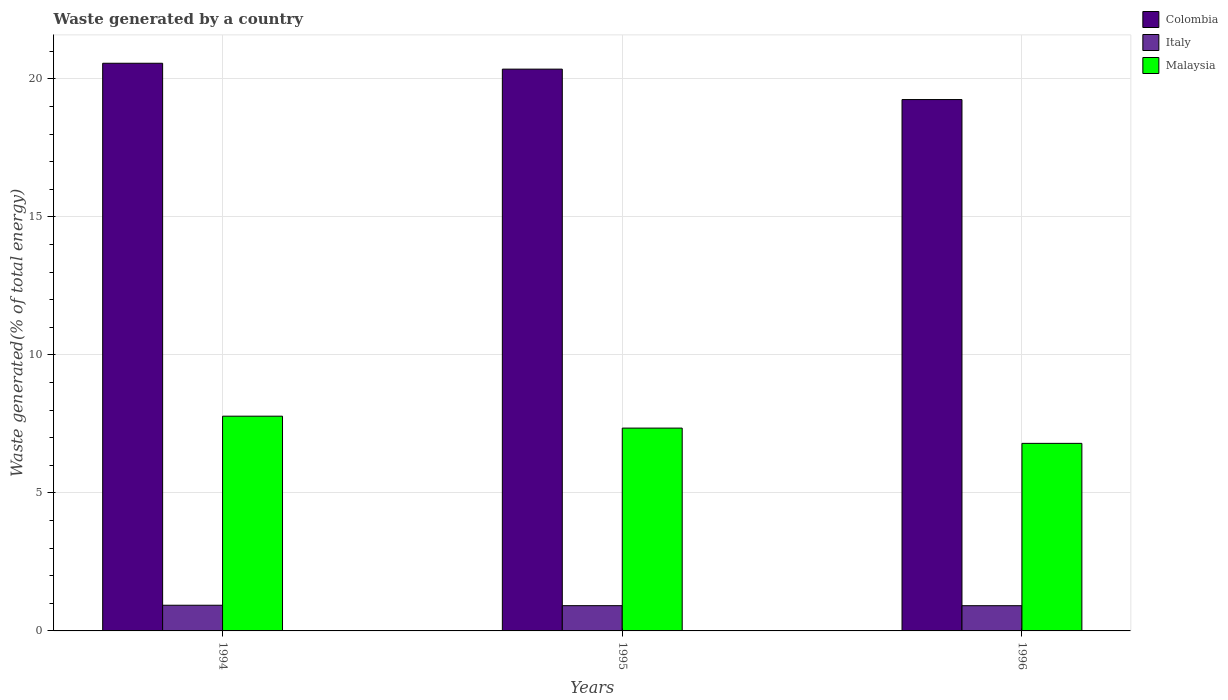How many bars are there on the 2nd tick from the right?
Make the answer very short. 3. What is the label of the 2nd group of bars from the left?
Make the answer very short. 1995. What is the total waste generated in Malaysia in 1995?
Offer a terse response. 7.35. Across all years, what is the maximum total waste generated in Italy?
Give a very brief answer. 0.93. Across all years, what is the minimum total waste generated in Colombia?
Your answer should be compact. 19.25. In which year was the total waste generated in Colombia maximum?
Provide a short and direct response. 1994. In which year was the total waste generated in Colombia minimum?
Your response must be concise. 1996. What is the total total waste generated in Colombia in the graph?
Keep it short and to the point. 60.17. What is the difference between the total waste generated in Italy in 1994 and that in 1996?
Offer a terse response. 0.02. What is the difference between the total waste generated in Malaysia in 1996 and the total waste generated in Italy in 1994?
Ensure brevity in your answer.  5.86. What is the average total waste generated in Malaysia per year?
Make the answer very short. 7.31. In the year 1996, what is the difference between the total waste generated in Malaysia and total waste generated in Colombia?
Your answer should be very brief. -12.46. In how many years, is the total waste generated in Colombia greater than 16 %?
Your answer should be very brief. 3. What is the ratio of the total waste generated in Colombia in 1995 to that in 1996?
Offer a terse response. 1.06. Is the total waste generated in Colombia in 1995 less than that in 1996?
Your response must be concise. No. What is the difference between the highest and the second highest total waste generated in Colombia?
Ensure brevity in your answer.  0.21. What is the difference between the highest and the lowest total waste generated in Malaysia?
Offer a very short reply. 0.99. In how many years, is the total waste generated in Italy greater than the average total waste generated in Italy taken over all years?
Give a very brief answer. 1. Is the sum of the total waste generated in Italy in 1995 and 1996 greater than the maximum total waste generated in Colombia across all years?
Your response must be concise. No. What does the 3rd bar from the left in 1996 represents?
Offer a very short reply. Malaysia. Are all the bars in the graph horizontal?
Your response must be concise. No. Does the graph contain any zero values?
Ensure brevity in your answer.  No. How many legend labels are there?
Your response must be concise. 3. What is the title of the graph?
Provide a succinct answer. Waste generated by a country. What is the label or title of the X-axis?
Provide a short and direct response. Years. What is the label or title of the Y-axis?
Provide a succinct answer. Waste generated(% of total energy). What is the Waste generated(% of total energy) of Colombia in 1994?
Offer a terse response. 20.57. What is the Waste generated(% of total energy) in Italy in 1994?
Your answer should be compact. 0.93. What is the Waste generated(% of total energy) of Malaysia in 1994?
Offer a terse response. 7.78. What is the Waste generated(% of total energy) in Colombia in 1995?
Your answer should be compact. 20.35. What is the Waste generated(% of total energy) of Italy in 1995?
Offer a terse response. 0.92. What is the Waste generated(% of total energy) in Malaysia in 1995?
Offer a terse response. 7.35. What is the Waste generated(% of total energy) in Colombia in 1996?
Provide a succinct answer. 19.25. What is the Waste generated(% of total energy) of Italy in 1996?
Your answer should be very brief. 0.91. What is the Waste generated(% of total energy) in Malaysia in 1996?
Ensure brevity in your answer.  6.79. Across all years, what is the maximum Waste generated(% of total energy) in Colombia?
Offer a very short reply. 20.57. Across all years, what is the maximum Waste generated(% of total energy) of Italy?
Offer a very short reply. 0.93. Across all years, what is the maximum Waste generated(% of total energy) of Malaysia?
Your answer should be very brief. 7.78. Across all years, what is the minimum Waste generated(% of total energy) in Colombia?
Ensure brevity in your answer.  19.25. Across all years, what is the minimum Waste generated(% of total energy) of Italy?
Your answer should be very brief. 0.91. Across all years, what is the minimum Waste generated(% of total energy) of Malaysia?
Your response must be concise. 6.79. What is the total Waste generated(% of total energy) in Colombia in the graph?
Offer a terse response. 60.17. What is the total Waste generated(% of total energy) in Italy in the graph?
Ensure brevity in your answer.  2.76. What is the total Waste generated(% of total energy) in Malaysia in the graph?
Provide a short and direct response. 21.92. What is the difference between the Waste generated(% of total energy) of Colombia in 1994 and that in 1995?
Your answer should be very brief. 0.21. What is the difference between the Waste generated(% of total energy) in Italy in 1994 and that in 1995?
Provide a short and direct response. 0.02. What is the difference between the Waste generated(% of total energy) in Malaysia in 1994 and that in 1995?
Your response must be concise. 0.43. What is the difference between the Waste generated(% of total energy) in Colombia in 1994 and that in 1996?
Make the answer very short. 1.31. What is the difference between the Waste generated(% of total energy) of Italy in 1994 and that in 1996?
Keep it short and to the point. 0.02. What is the difference between the Waste generated(% of total energy) of Malaysia in 1994 and that in 1996?
Offer a terse response. 0.98. What is the difference between the Waste generated(% of total energy) of Colombia in 1995 and that in 1996?
Offer a terse response. 1.1. What is the difference between the Waste generated(% of total energy) in Italy in 1995 and that in 1996?
Keep it short and to the point. 0. What is the difference between the Waste generated(% of total energy) in Malaysia in 1995 and that in 1996?
Your answer should be compact. 0.55. What is the difference between the Waste generated(% of total energy) of Colombia in 1994 and the Waste generated(% of total energy) of Italy in 1995?
Keep it short and to the point. 19.65. What is the difference between the Waste generated(% of total energy) of Colombia in 1994 and the Waste generated(% of total energy) of Malaysia in 1995?
Give a very brief answer. 13.22. What is the difference between the Waste generated(% of total energy) of Italy in 1994 and the Waste generated(% of total energy) of Malaysia in 1995?
Offer a very short reply. -6.42. What is the difference between the Waste generated(% of total energy) in Colombia in 1994 and the Waste generated(% of total energy) in Italy in 1996?
Make the answer very short. 19.65. What is the difference between the Waste generated(% of total energy) in Colombia in 1994 and the Waste generated(% of total energy) in Malaysia in 1996?
Your answer should be very brief. 13.77. What is the difference between the Waste generated(% of total energy) in Italy in 1994 and the Waste generated(% of total energy) in Malaysia in 1996?
Give a very brief answer. -5.86. What is the difference between the Waste generated(% of total energy) in Colombia in 1995 and the Waste generated(% of total energy) in Italy in 1996?
Provide a short and direct response. 19.44. What is the difference between the Waste generated(% of total energy) of Colombia in 1995 and the Waste generated(% of total energy) of Malaysia in 1996?
Keep it short and to the point. 13.56. What is the difference between the Waste generated(% of total energy) in Italy in 1995 and the Waste generated(% of total energy) in Malaysia in 1996?
Give a very brief answer. -5.88. What is the average Waste generated(% of total energy) in Colombia per year?
Offer a terse response. 20.06. What is the average Waste generated(% of total energy) of Italy per year?
Your response must be concise. 0.92. What is the average Waste generated(% of total energy) of Malaysia per year?
Provide a short and direct response. 7.31. In the year 1994, what is the difference between the Waste generated(% of total energy) of Colombia and Waste generated(% of total energy) of Italy?
Give a very brief answer. 19.64. In the year 1994, what is the difference between the Waste generated(% of total energy) of Colombia and Waste generated(% of total energy) of Malaysia?
Your response must be concise. 12.79. In the year 1994, what is the difference between the Waste generated(% of total energy) in Italy and Waste generated(% of total energy) in Malaysia?
Give a very brief answer. -6.85. In the year 1995, what is the difference between the Waste generated(% of total energy) of Colombia and Waste generated(% of total energy) of Italy?
Your answer should be compact. 19.44. In the year 1995, what is the difference between the Waste generated(% of total energy) of Colombia and Waste generated(% of total energy) of Malaysia?
Offer a terse response. 13.01. In the year 1995, what is the difference between the Waste generated(% of total energy) of Italy and Waste generated(% of total energy) of Malaysia?
Give a very brief answer. -6.43. In the year 1996, what is the difference between the Waste generated(% of total energy) of Colombia and Waste generated(% of total energy) of Italy?
Your response must be concise. 18.34. In the year 1996, what is the difference between the Waste generated(% of total energy) of Colombia and Waste generated(% of total energy) of Malaysia?
Provide a succinct answer. 12.46. In the year 1996, what is the difference between the Waste generated(% of total energy) of Italy and Waste generated(% of total energy) of Malaysia?
Offer a very short reply. -5.88. What is the ratio of the Waste generated(% of total energy) of Colombia in 1994 to that in 1995?
Keep it short and to the point. 1.01. What is the ratio of the Waste generated(% of total energy) in Italy in 1994 to that in 1995?
Provide a succinct answer. 1.02. What is the ratio of the Waste generated(% of total energy) in Malaysia in 1994 to that in 1995?
Your answer should be compact. 1.06. What is the ratio of the Waste generated(% of total energy) in Colombia in 1994 to that in 1996?
Your answer should be very brief. 1.07. What is the ratio of the Waste generated(% of total energy) of Italy in 1994 to that in 1996?
Make the answer very short. 1.02. What is the ratio of the Waste generated(% of total energy) of Malaysia in 1994 to that in 1996?
Provide a short and direct response. 1.15. What is the ratio of the Waste generated(% of total energy) of Colombia in 1995 to that in 1996?
Offer a terse response. 1.06. What is the ratio of the Waste generated(% of total energy) of Italy in 1995 to that in 1996?
Make the answer very short. 1. What is the ratio of the Waste generated(% of total energy) of Malaysia in 1995 to that in 1996?
Your answer should be very brief. 1.08. What is the difference between the highest and the second highest Waste generated(% of total energy) of Colombia?
Provide a succinct answer. 0.21. What is the difference between the highest and the second highest Waste generated(% of total energy) of Italy?
Offer a terse response. 0.02. What is the difference between the highest and the second highest Waste generated(% of total energy) of Malaysia?
Provide a short and direct response. 0.43. What is the difference between the highest and the lowest Waste generated(% of total energy) in Colombia?
Your answer should be very brief. 1.31. What is the difference between the highest and the lowest Waste generated(% of total energy) of Italy?
Your answer should be compact. 0.02. What is the difference between the highest and the lowest Waste generated(% of total energy) of Malaysia?
Ensure brevity in your answer.  0.98. 